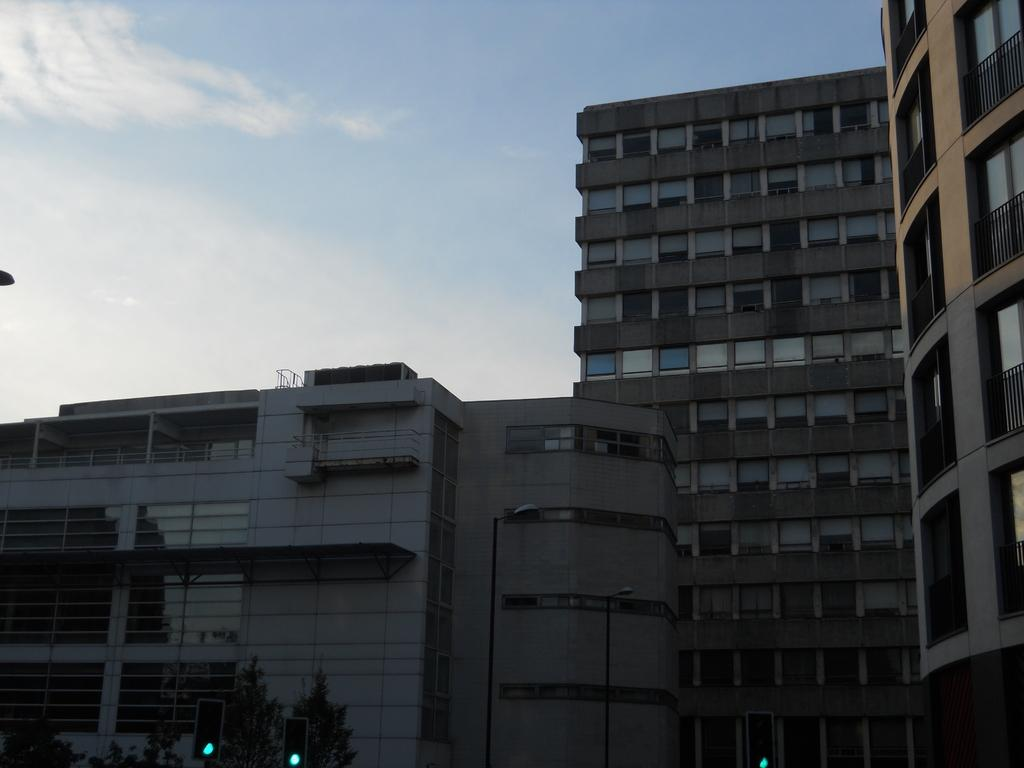What type of structures can be seen in the image? There are buildings in the image. What else can be seen in the image besides buildings? There are poles, lights, traffic signals, and branches visible in the image. What might be used to control traffic in the image? Traffic signals are present in the image to control traffic. What is visible in the background of the image? The sky is visible in the background of the image, and there are clouds in the sky. Can you tell me how many members are in the group that is performing in the image? There is no group performing in the image; it features buildings, poles, lights, traffic signals, branches, and a sky with clouds. What type of rail system is present in the image? There is no rail system present in the image; it features buildings, poles, lights, traffic signals, branches, and a sky with clouds. 